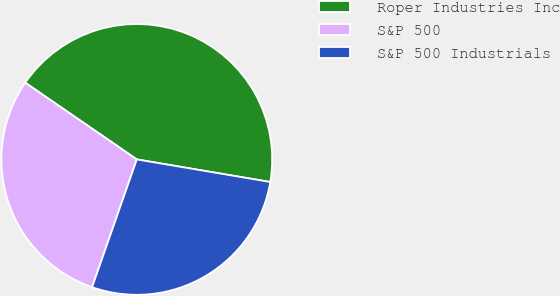Convert chart. <chart><loc_0><loc_0><loc_500><loc_500><pie_chart><fcel>Roper Industries Inc<fcel>S&P 500<fcel>S&P 500 Industrials<nl><fcel>43.08%<fcel>29.23%<fcel>27.69%<nl></chart> 